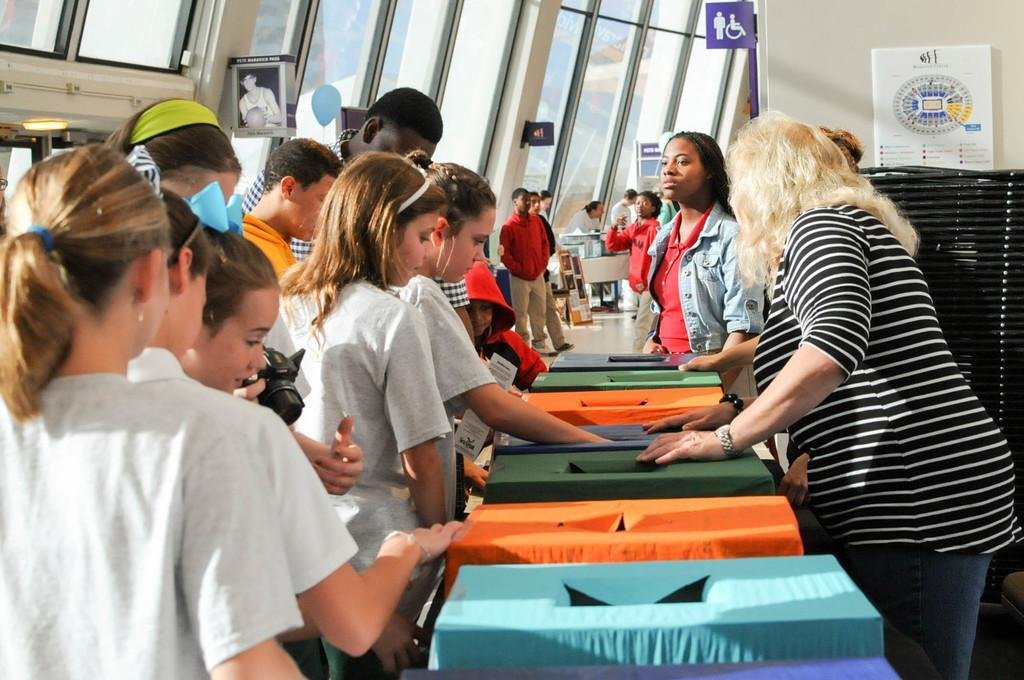In one or two sentences, can you explain what this image depicts? Here we can see some persons and there are boxes. This is floor and there is a table. In the background we can see a wall, boards, light, and glasses. 